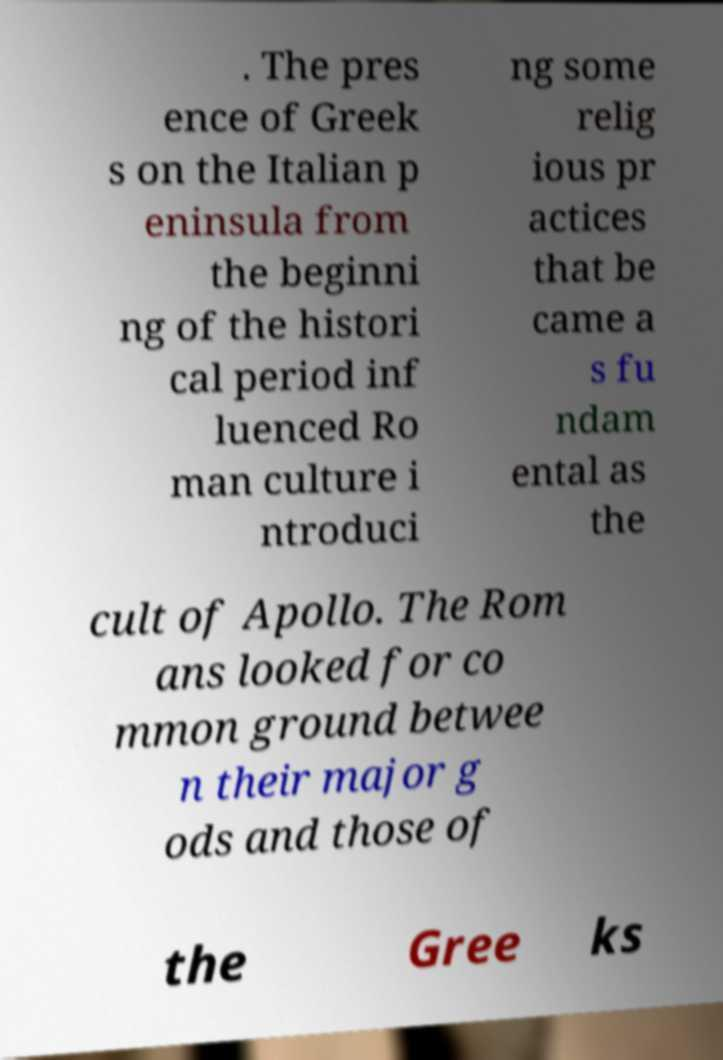Could you assist in decoding the text presented in this image and type it out clearly? . The pres ence of Greek s on the Italian p eninsula from the beginni ng of the histori cal period inf luenced Ro man culture i ntroduci ng some relig ious pr actices that be came a s fu ndam ental as the cult of Apollo. The Rom ans looked for co mmon ground betwee n their major g ods and those of the Gree ks 